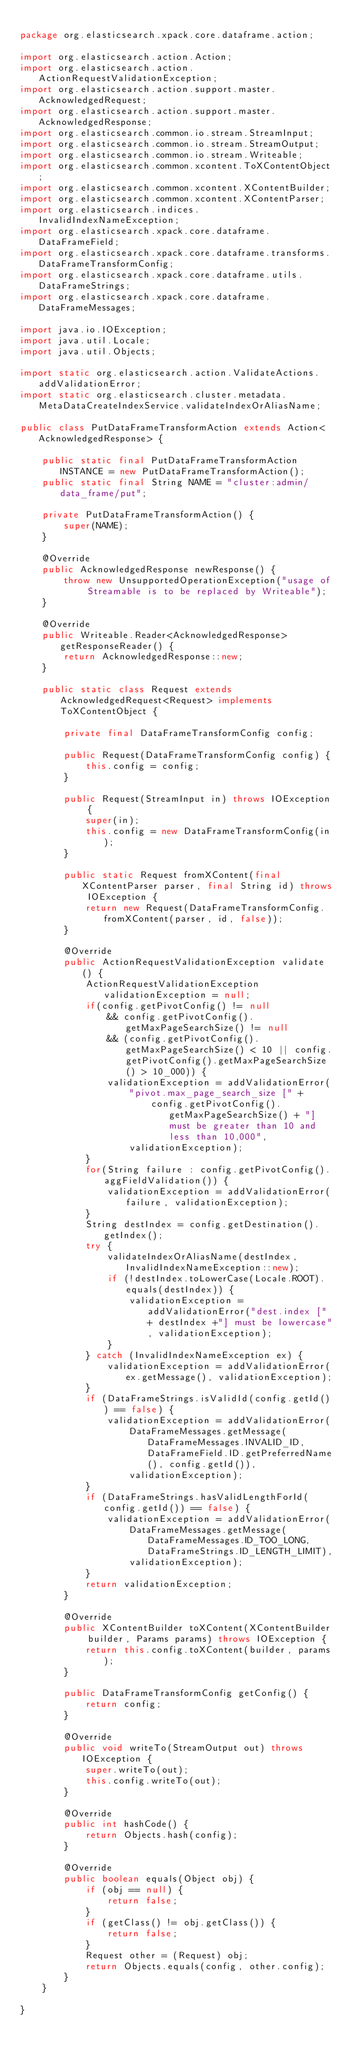<code> <loc_0><loc_0><loc_500><loc_500><_Java_>
package org.elasticsearch.xpack.core.dataframe.action;

import org.elasticsearch.action.Action;
import org.elasticsearch.action.ActionRequestValidationException;
import org.elasticsearch.action.support.master.AcknowledgedRequest;
import org.elasticsearch.action.support.master.AcknowledgedResponse;
import org.elasticsearch.common.io.stream.StreamInput;
import org.elasticsearch.common.io.stream.StreamOutput;
import org.elasticsearch.common.io.stream.Writeable;
import org.elasticsearch.common.xcontent.ToXContentObject;
import org.elasticsearch.common.xcontent.XContentBuilder;
import org.elasticsearch.common.xcontent.XContentParser;
import org.elasticsearch.indices.InvalidIndexNameException;
import org.elasticsearch.xpack.core.dataframe.DataFrameField;
import org.elasticsearch.xpack.core.dataframe.transforms.DataFrameTransformConfig;
import org.elasticsearch.xpack.core.dataframe.utils.DataFrameStrings;
import org.elasticsearch.xpack.core.dataframe.DataFrameMessages;

import java.io.IOException;
import java.util.Locale;
import java.util.Objects;

import static org.elasticsearch.action.ValidateActions.addValidationError;
import static org.elasticsearch.cluster.metadata.MetaDataCreateIndexService.validateIndexOrAliasName;

public class PutDataFrameTransformAction extends Action<AcknowledgedResponse> {

    public static final PutDataFrameTransformAction INSTANCE = new PutDataFrameTransformAction();
    public static final String NAME = "cluster:admin/data_frame/put";

    private PutDataFrameTransformAction() {
        super(NAME);
    }

    @Override
    public AcknowledgedResponse newResponse() {
        throw new UnsupportedOperationException("usage of Streamable is to be replaced by Writeable");
    }

    @Override
    public Writeable.Reader<AcknowledgedResponse> getResponseReader() {
        return AcknowledgedResponse::new;
    }

    public static class Request extends AcknowledgedRequest<Request> implements ToXContentObject {

        private final DataFrameTransformConfig config;

        public Request(DataFrameTransformConfig config) {
            this.config = config;
        }

        public Request(StreamInput in) throws IOException {
            super(in);
            this.config = new DataFrameTransformConfig(in);
        }

        public static Request fromXContent(final XContentParser parser, final String id) throws IOException {
            return new Request(DataFrameTransformConfig.fromXContent(parser, id, false));
        }

        @Override
        public ActionRequestValidationException validate() {
            ActionRequestValidationException validationException = null;
            if(config.getPivotConfig() != null
                && config.getPivotConfig().getMaxPageSearchSize() != null
                && (config.getPivotConfig().getMaxPageSearchSize() < 10 || config.getPivotConfig().getMaxPageSearchSize() > 10_000)) {
                validationException = addValidationError(
                    "pivot.max_page_search_size [" +
                        config.getPivotConfig().getMaxPageSearchSize() + "] must be greater than 10 and less than 10,000",
                    validationException);
            }
            for(String failure : config.getPivotConfig().aggFieldValidation()) {
                validationException = addValidationError(failure, validationException);
            }
            String destIndex = config.getDestination().getIndex();
            try {
                validateIndexOrAliasName(destIndex, InvalidIndexNameException::new);
                if (!destIndex.toLowerCase(Locale.ROOT).equals(destIndex)) {
                    validationException = addValidationError("dest.index [" + destIndex +"] must be lowercase", validationException);
                }
            } catch (InvalidIndexNameException ex) {
                validationException = addValidationError(ex.getMessage(), validationException);
            }
            if (DataFrameStrings.isValidId(config.getId()) == false) {
                validationException = addValidationError(
                    DataFrameMessages.getMessage(DataFrameMessages.INVALID_ID, DataFrameField.ID.getPreferredName(), config.getId()),
                    validationException);
            }
            if (DataFrameStrings.hasValidLengthForId(config.getId()) == false) {
                validationException = addValidationError(
                    DataFrameMessages.getMessage(DataFrameMessages.ID_TOO_LONG, DataFrameStrings.ID_LENGTH_LIMIT),
                    validationException);
            }
            return validationException;
        }

        @Override
        public XContentBuilder toXContent(XContentBuilder builder, Params params) throws IOException {
            return this.config.toXContent(builder, params);
        }

        public DataFrameTransformConfig getConfig() {
            return config;
        }

        @Override
        public void writeTo(StreamOutput out) throws IOException {
            super.writeTo(out);
            this.config.writeTo(out);
        }

        @Override
        public int hashCode() {
            return Objects.hash(config);
        }

        @Override
        public boolean equals(Object obj) {
            if (obj == null) {
                return false;
            }
            if (getClass() != obj.getClass()) {
                return false;
            }
            Request other = (Request) obj;
            return Objects.equals(config, other.config);
        }
    }

}
</code> 